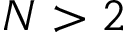Convert formula to latex. <formula><loc_0><loc_0><loc_500><loc_500>N > 2</formula> 